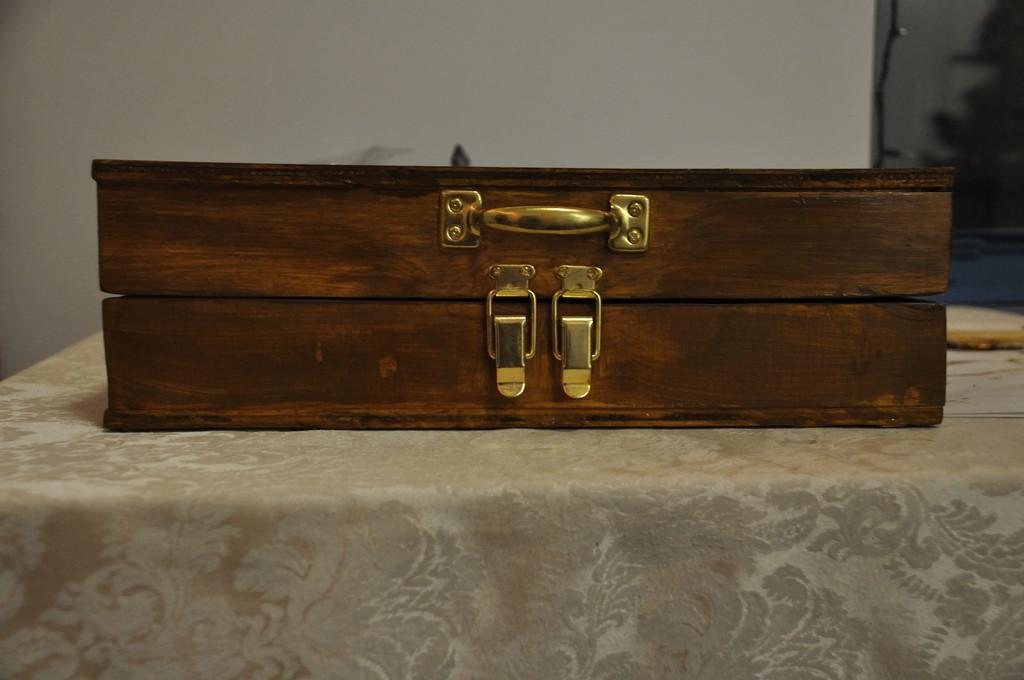What is the main object in the image? There is a box with a handle in the image. How many locks are on the box? The box has 2 locks. Where is the box located? The box is on a table. What can be seen in the background of the image? There is a wall visible in the background of the image. What type of airport is visible in the image? There is no airport present in the image; it features a box with a handle on a table. Are there any camping activities taking place in the image? There is no camping activity present in the image; it features a box with a handle on a table. 